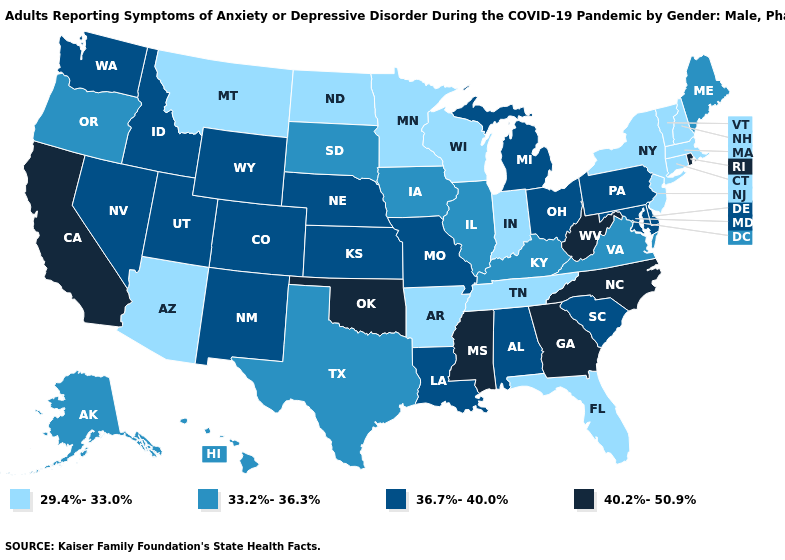What is the highest value in the West ?
Answer briefly. 40.2%-50.9%. Does North Carolina have the highest value in the South?
Keep it brief. Yes. What is the value of Nebraska?
Quick response, please. 36.7%-40.0%. Name the states that have a value in the range 29.4%-33.0%?
Quick response, please. Arizona, Arkansas, Connecticut, Florida, Indiana, Massachusetts, Minnesota, Montana, New Hampshire, New Jersey, New York, North Dakota, Tennessee, Vermont, Wisconsin. Does Arkansas have the lowest value in the USA?
Be succinct. Yes. Is the legend a continuous bar?
Concise answer only. No. How many symbols are there in the legend?
Write a very short answer. 4. What is the highest value in states that border Illinois?
Be succinct. 36.7%-40.0%. What is the lowest value in states that border Illinois?
Be succinct. 29.4%-33.0%. Does Utah have the same value as Iowa?
Quick response, please. No. What is the value of West Virginia?
Be succinct. 40.2%-50.9%. Name the states that have a value in the range 40.2%-50.9%?
Quick response, please. California, Georgia, Mississippi, North Carolina, Oklahoma, Rhode Island, West Virginia. Does Rhode Island have a lower value than Missouri?
Answer briefly. No. What is the value of Massachusetts?
Answer briefly. 29.4%-33.0%. Which states have the lowest value in the MidWest?
Short answer required. Indiana, Minnesota, North Dakota, Wisconsin. 